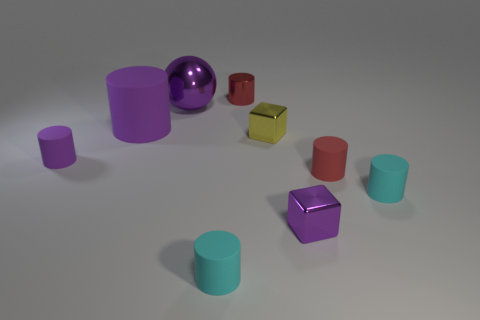What is the size of the sphere that is the same color as the large matte thing?
Provide a succinct answer. Large. There is a large ball that is the same color as the large matte object; what is it made of?
Ensure brevity in your answer.  Metal. Is the size of the red metallic thing that is behind the purple sphere the same as the small purple rubber cylinder?
Provide a succinct answer. Yes. There is a small cyan object that is left of the red thing that is behind the big purple ball; what number of cyan matte cylinders are to the right of it?
Your response must be concise. 1. How many gray things are either cylinders or tiny rubber things?
Your answer should be very brief. 0. There is a large thing that is made of the same material as the yellow cube; what color is it?
Ensure brevity in your answer.  Purple. What number of large things are either purple cubes or cyan cylinders?
Keep it short and to the point. 0. Are there fewer big green matte blocks than tiny purple rubber cylinders?
Offer a very short reply. Yes. What color is the other tiny thing that is the same shape as the tiny yellow metallic object?
Keep it short and to the point. Purple. Are there any other things that have the same shape as the yellow metal thing?
Provide a short and direct response. Yes. 